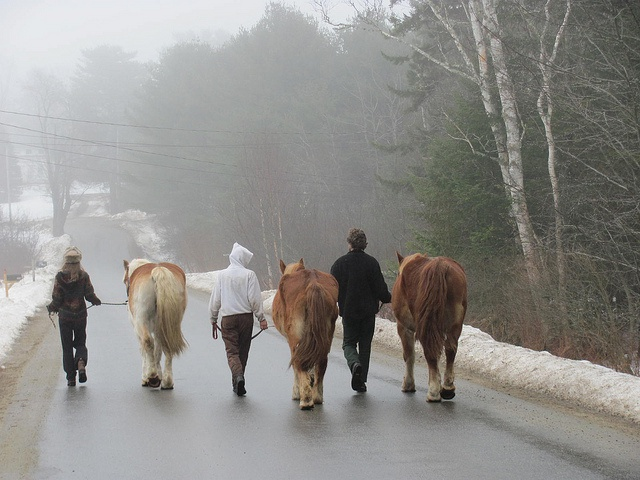Describe the objects in this image and their specific colors. I can see horse in lavender, maroon, black, and gray tones, horse in lavender, gray, brown, and black tones, horse in lavender, gray, darkgray, and tan tones, people in lavender, darkgray, black, lightgray, and gray tones, and people in lavender, black, and gray tones in this image. 